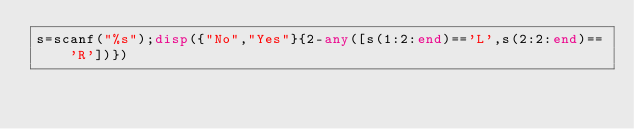Convert code to text. <code><loc_0><loc_0><loc_500><loc_500><_Octave_>s=scanf("%s");disp({"No","Yes"}{2-any([s(1:2:end)=='L',s(2:2:end)=='R'])})</code> 